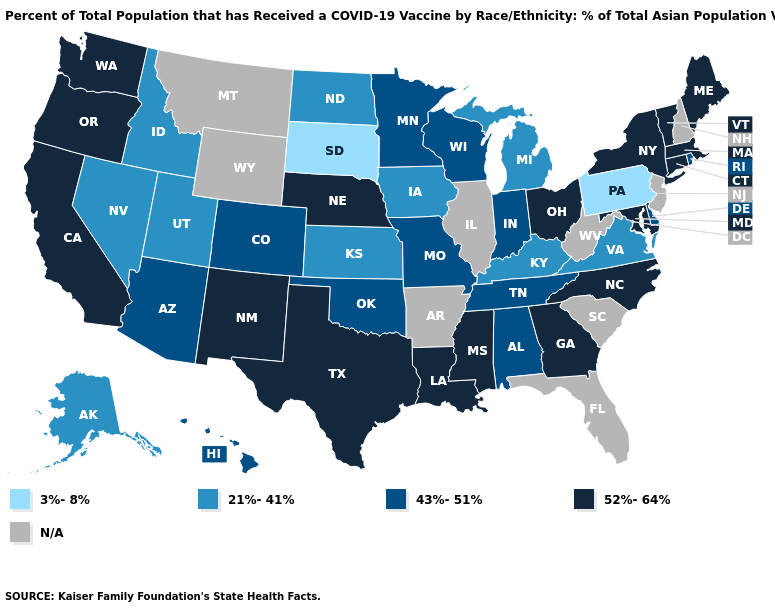What is the value of Connecticut?
Concise answer only. 52%-64%. Among the states that border Colorado , which have the lowest value?
Answer briefly. Kansas, Utah. Is the legend a continuous bar?
Keep it brief. No. Is the legend a continuous bar?
Short answer required. No. What is the value of Alaska?
Quick response, please. 21%-41%. Does Pennsylvania have the lowest value in the Northeast?
Write a very short answer. Yes. Name the states that have a value in the range 52%-64%?
Quick response, please. California, Connecticut, Georgia, Louisiana, Maine, Maryland, Massachusetts, Mississippi, Nebraska, New Mexico, New York, North Carolina, Ohio, Oregon, Texas, Vermont, Washington. What is the highest value in the USA?
Be succinct. 52%-64%. Does the map have missing data?
Quick response, please. Yes. Among the states that border Tennessee , does Georgia have the highest value?
Short answer required. Yes. What is the value of Arkansas?
Give a very brief answer. N/A. What is the lowest value in the USA?
Be succinct. 3%-8%. Among the states that border Mississippi , does Louisiana have the highest value?
Keep it brief. Yes. What is the value of Texas?
Quick response, please. 52%-64%. 